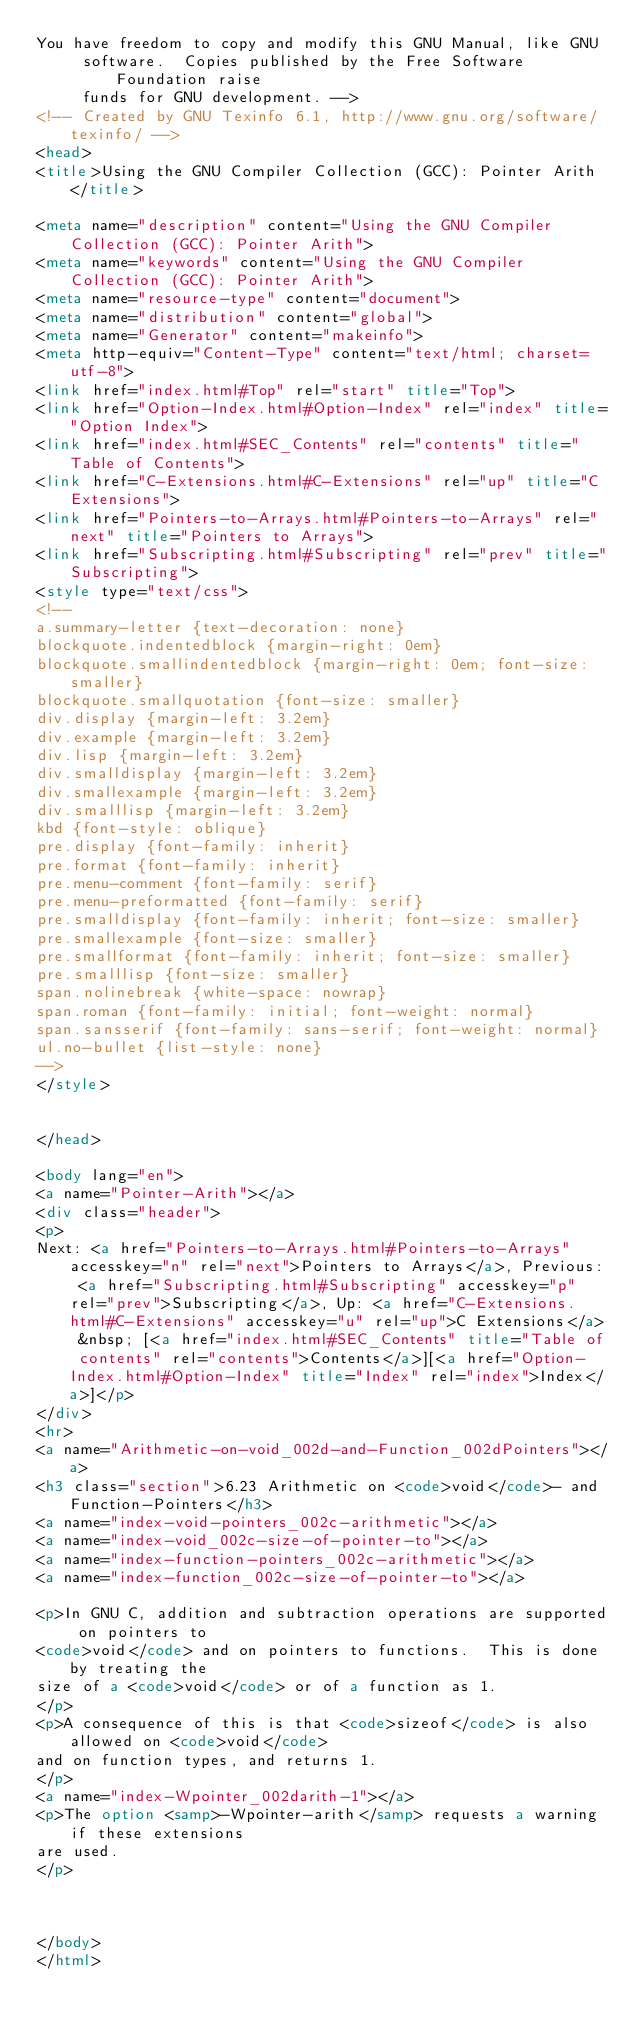Convert code to text. <code><loc_0><loc_0><loc_500><loc_500><_HTML_>You have freedom to copy and modify this GNU Manual, like GNU
     software.  Copies published by the Free Software Foundation raise
     funds for GNU development. -->
<!-- Created by GNU Texinfo 6.1, http://www.gnu.org/software/texinfo/ -->
<head>
<title>Using the GNU Compiler Collection (GCC): Pointer Arith</title>

<meta name="description" content="Using the GNU Compiler Collection (GCC): Pointer Arith">
<meta name="keywords" content="Using the GNU Compiler Collection (GCC): Pointer Arith">
<meta name="resource-type" content="document">
<meta name="distribution" content="global">
<meta name="Generator" content="makeinfo">
<meta http-equiv="Content-Type" content="text/html; charset=utf-8">
<link href="index.html#Top" rel="start" title="Top">
<link href="Option-Index.html#Option-Index" rel="index" title="Option Index">
<link href="index.html#SEC_Contents" rel="contents" title="Table of Contents">
<link href="C-Extensions.html#C-Extensions" rel="up" title="C Extensions">
<link href="Pointers-to-Arrays.html#Pointers-to-Arrays" rel="next" title="Pointers to Arrays">
<link href="Subscripting.html#Subscripting" rel="prev" title="Subscripting">
<style type="text/css">
<!--
a.summary-letter {text-decoration: none}
blockquote.indentedblock {margin-right: 0em}
blockquote.smallindentedblock {margin-right: 0em; font-size: smaller}
blockquote.smallquotation {font-size: smaller}
div.display {margin-left: 3.2em}
div.example {margin-left: 3.2em}
div.lisp {margin-left: 3.2em}
div.smalldisplay {margin-left: 3.2em}
div.smallexample {margin-left: 3.2em}
div.smalllisp {margin-left: 3.2em}
kbd {font-style: oblique}
pre.display {font-family: inherit}
pre.format {font-family: inherit}
pre.menu-comment {font-family: serif}
pre.menu-preformatted {font-family: serif}
pre.smalldisplay {font-family: inherit; font-size: smaller}
pre.smallexample {font-size: smaller}
pre.smallformat {font-family: inherit; font-size: smaller}
pre.smalllisp {font-size: smaller}
span.nolinebreak {white-space: nowrap}
span.roman {font-family: initial; font-weight: normal}
span.sansserif {font-family: sans-serif; font-weight: normal}
ul.no-bullet {list-style: none}
-->
</style>


</head>

<body lang="en">
<a name="Pointer-Arith"></a>
<div class="header">
<p>
Next: <a href="Pointers-to-Arrays.html#Pointers-to-Arrays" accesskey="n" rel="next">Pointers to Arrays</a>, Previous: <a href="Subscripting.html#Subscripting" accesskey="p" rel="prev">Subscripting</a>, Up: <a href="C-Extensions.html#C-Extensions" accesskey="u" rel="up">C Extensions</a> &nbsp; [<a href="index.html#SEC_Contents" title="Table of contents" rel="contents">Contents</a>][<a href="Option-Index.html#Option-Index" title="Index" rel="index">Index</a>]</p>
</div>
<hr>
<a name="Arithmetic-on-void_002d-and-Function_002dPointers"></a>
<h3 class="section">6.23 Arithmetic on <code>void</code>- and Function-Pointers</h3>
<a name="index-void-pointers_002c-arithmetic"></a>
<a name="index-void_002c-size-of-pointer-to"></a>
<a name="index-function-pointers_002c-arithmetic"></a>
<a name="index-function_002c-size-of-pointer-to"></a>

<p>In GNU C, addition and subtraction operations are supported on pointers to
<code>void</code> and on pointers to functions.  This is done by treating the
size of a <code>void</code> or of a function as 1.
</p>
<p>A consequence of this is that <code>sizeof</code> is also allowed on <code>void</code>
and on function types, and returns 1.
</p>
<a name="index-Wpointer_002darith-1"></a>
<p>The option <samp>-Wpointer-arith</samp> requests a warning if these extensions
are used.
</p>



</body>
</html>
</code> 